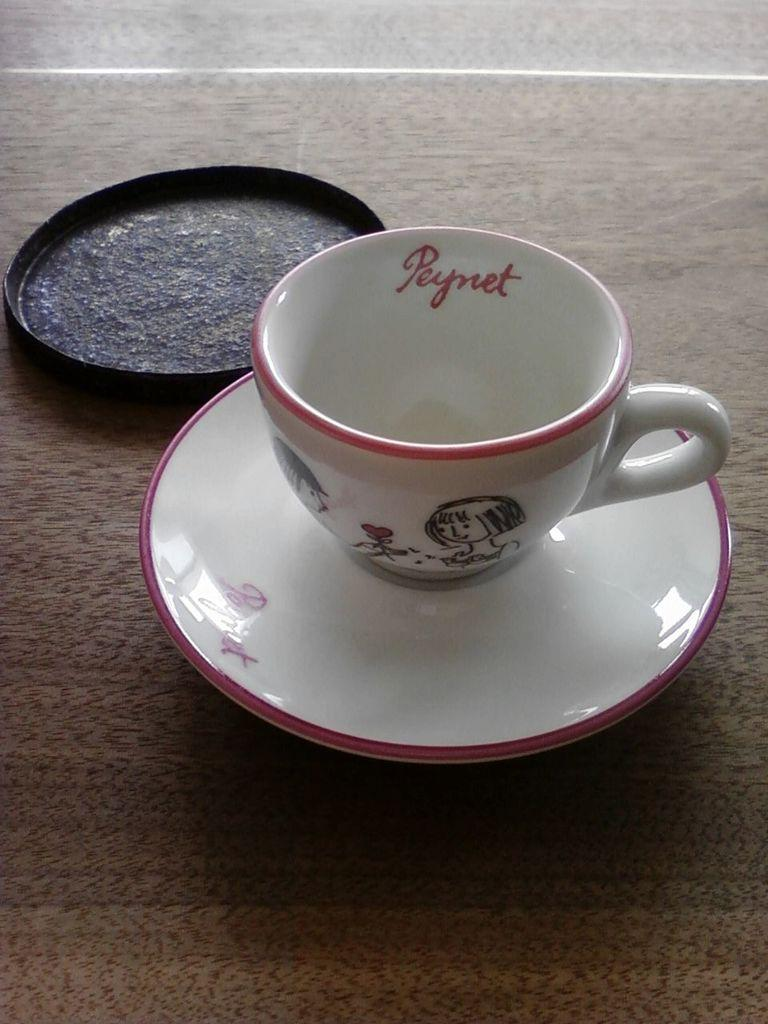What type of furniture is present in the image? There is a table in the image. What is placed on the table? There is a cup and a saucer on the table. Are there any other objects on the table? Yes, there is another object on the table. How does the lettuce turn into a salad in the image? There is no lettuce or salad present in the image. 